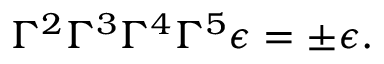Convert formula to latex. <formula><loc_0><loc_0><loc_500><loc_500>\Gamma ^ { 2 } \Gamma ^ { 3 } \Gamma ^ { 4 } \Gamma ^ { 5 } \epsilon = \pm \epsilon .</formula> 